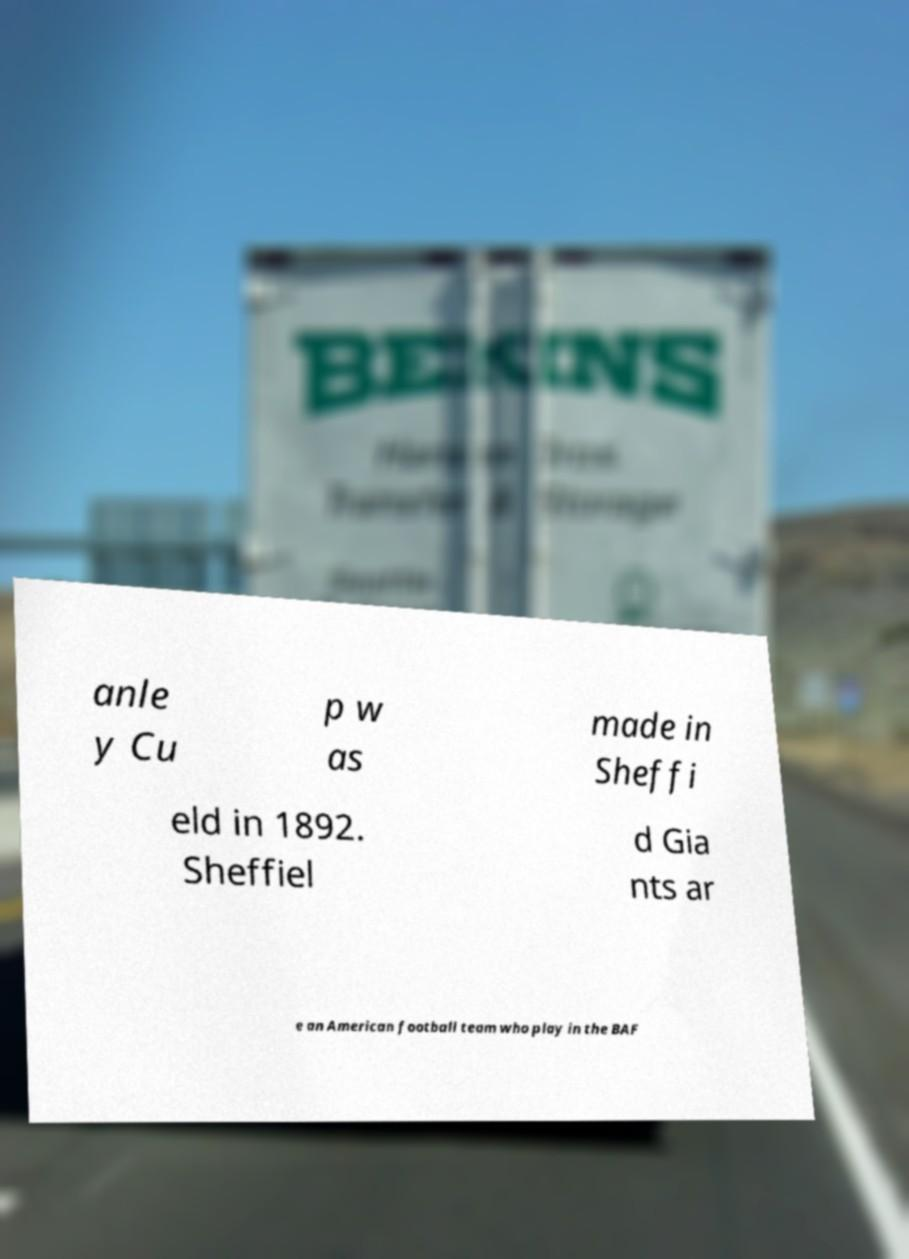Can you accurately transcribe the text from the provided image for me? anle y Cu p w as made in Sheffi eld in 1892. Sheffiel d Gia nts ar e an American football team who play in the BAF 